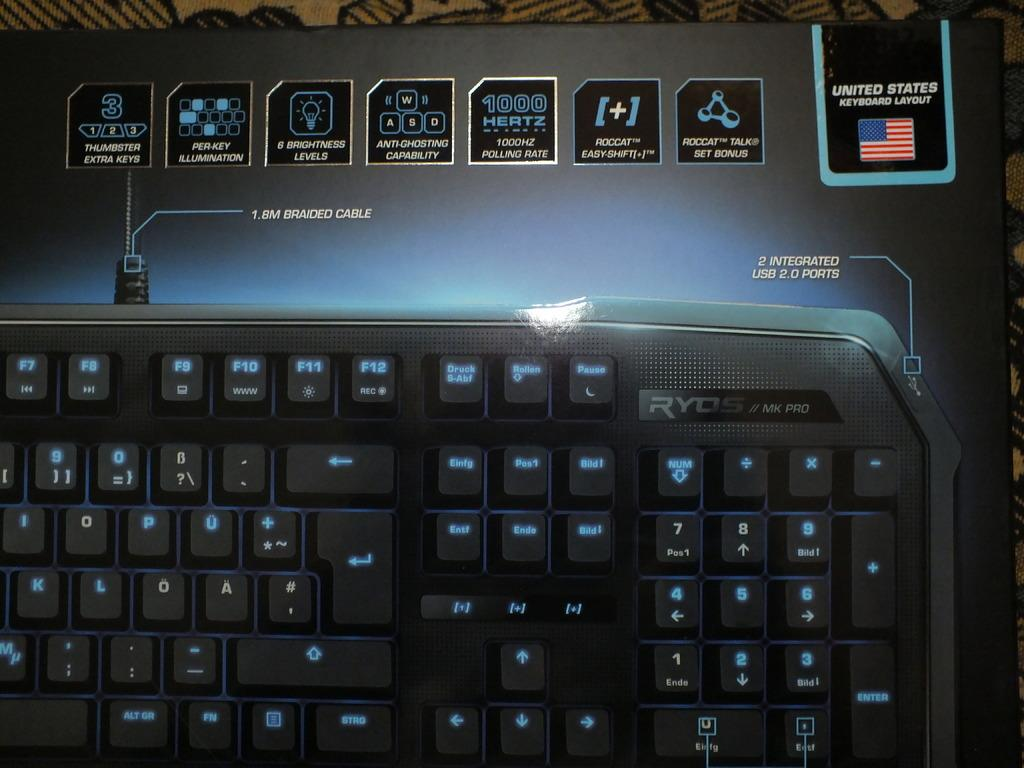Provide a one-sentence caption for the provided image. A black keyboard with the USA on it. 